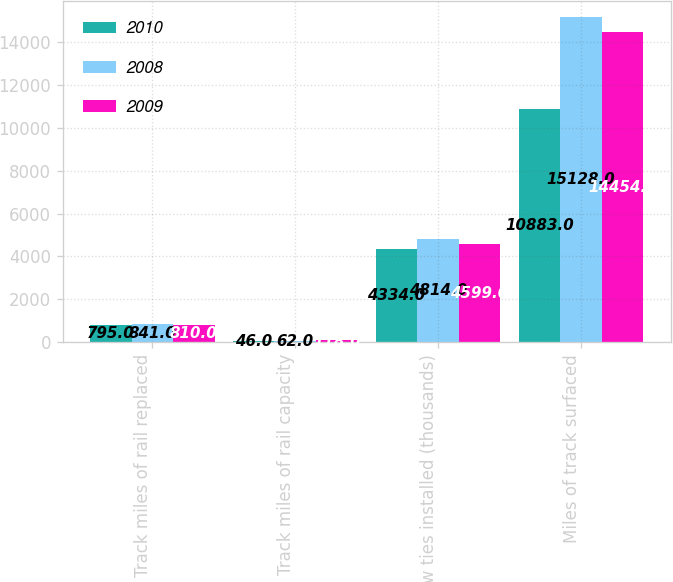Convert chart to OTSL. <chart><loc_0><loc_0><loc_500><loc_500><stacked_bar_chart><ecel><fcel>Track miles of rail replaced<fcel>Track miles of rail capacity<fcel>New ties installed (thousands)<fcel>Miles of track surfaced<nl><fcel>2010<fcel>795<fcel>46<fcel>4334<fcel>10883<nl><fcel>2008<fcel>841<fcel>62<fcel>4814<fcel>15128<nl><fcel>2009<fcel>810<fcel>118<fcel>4599<fcel>14454<nl></chart> 